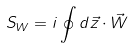<formula> <loc_0><loc_0><loc_500><loc_500>S _ { W } = i \oint d \vec { z } \cdot \vec { W }</formula> 